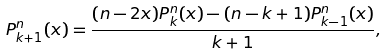<formula> <loc_0><loc_0><loc_500><loc_500>P _ { k + 1 } ^ { n } ( x ) = \frac { ( n - 2 x ) P _ { k } ^ { n } ( x ) - ( n - k + 1 ) P _ { k - 1 } ^ { n } ( x ) } { k + 1 } ,</formula> 